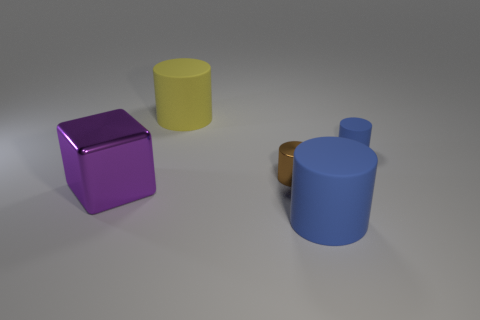Does the brown object have the same size as the yellow thing?
Ensure brevity in your answer.  No. How many things are large purple matte cylinders or rubber objects that are behind the small shiny cylinder?
Offer a very short reply. 2. What is the material of the large blue cylinder?
Offer a very short reply. Rubber. Is there anything else of the same color as the tiny matte cylinder?
Offer a terse response. Yes. Does the large metal object have the same shape as the large yellow thing?
Provide a short and direct response. No. What is the size of the thing that is left of the big cylinder behind the blue object that is in front of the small blue matte object?
Your answer should be compact. Large. What number of other objects are there of the same material as the big blue thing?
Your answer should be very brief. 2. There is a large rubber cylinder to the right of the tiny shiny object; what is its color?
Your answer should be very brief. Blue. There is a large object on the right side of the rubber object left of the blue matte cylinder that is in front of the big purple thing; what is its material?
Your answer should be very brief. Rubber. Are there any brown objects of the same shape as the yellow rubber object?
Offer a terse response. Yes. 